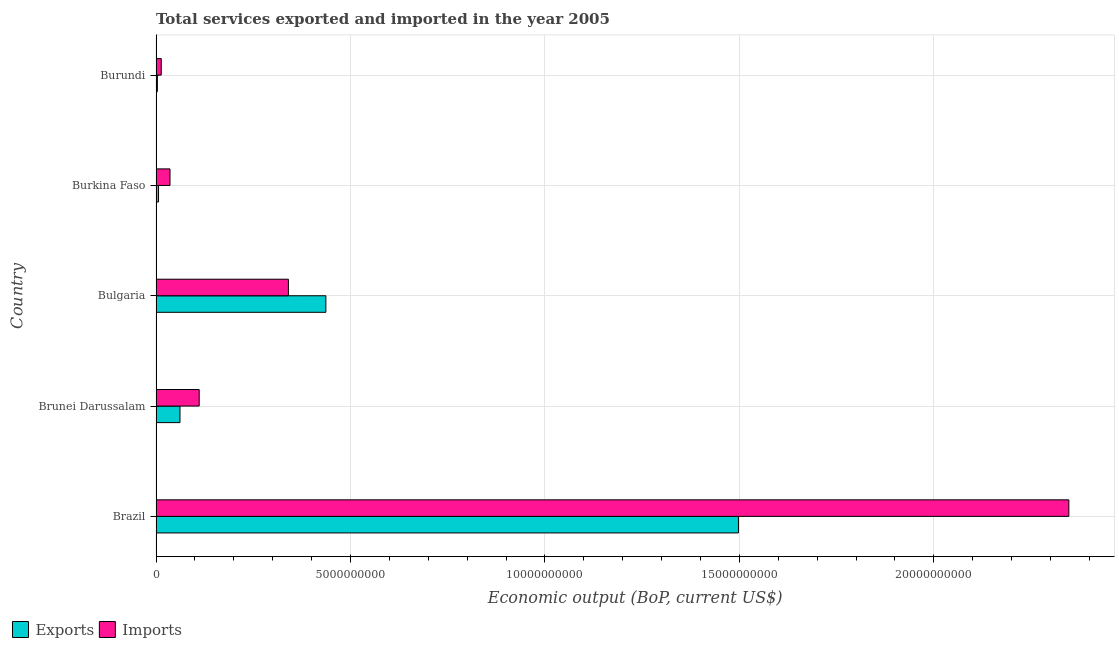Are the number of bars on each tick of the Y-axis equal?
Provide a succinct answer. Yes. How many bars are there on the 4th tick from the top?
Ensure brevity in your answer.  2. How many bars are there on the 1st tick from the bottom?
Keep it short and to the point. 2. What is the label of the 1st group of bars from the top?
Your response must be concise. Burundi. What is the amount of service exports in Brunei Darussalam?
Keep it short and to the point. 6.16e+08. Across all countries, what is the maximum amount of service exports?
Provide a succinct answer. 1.50e+1. Across all countries, what is the minimum amount of service exports?
Make the answer very short. 3.48e+07. In which country was the amount of service exports maximum?
Make the answer very short. Brazil. In which country was the amount of service imports minimum?
Your answer should be very brief. Burundi. What is the total amount of service exports in the graph?
Keep it short and to the point. 2.01e+1. What is the difference between the amount of service exports in Brazil and that in Bulgaria?
Your answer should be very brief. 1.06e+1. What is the difference between the amount of service exports in Brazil and the amount of service imports in Burkina Faso?
Give a very brief answer. 1.46e+1. What is the average amount of service exports per country?
Keep it short and to the point. 4.01e+09. What is the difference between the amount of service exports and amount of service imports in Brazil?
Give a very brief answer. -8.50e+09. What is the ratio of the amount of service imports in Burkina Faso to that in Burundi?
Offer a very short reply. 2.68. Is the amount of service exports in Brazil less than that in Bulgaria?
Keep it short and to the point. No. What is the difference between the highest and the second highest amount of service imports?
Your answer should be very brief. 2.01e+1. What is the difference between the highest and the lowest amount of service imports?
Keep it short and to the point. 2.33e+1. What does the 2nd bar from the top in Brunei Darussalam represents?
Provide a short and direct response. Exports. What does the 2nd bar from the bottom in Brunei Darussalam represents?
Your response must be concise. Imports. How many bars are there?
Offer a very short reply. 10. How many countries are there in the graph?
Your answer should be compact. 5. Where does the legend appear in the graph?
Your answer should be very brief. Bottom left. How are the legend labels stacked?
Your answer should be very brief. Horizontal. What is the title of the graph?
Offer a very short reply. Total services exported and imported in the year 2005. Does "Time to import" appear as one of the legend labels in the graph?
Your answer should be very brief. No. What is the label or title of the X-axis?
Provide a short and direct response. Economic output (BoP, current US$). What is the Economic output (BoP, current US$) of Exports in Brazil?
Keep it short and to the point. 1.50e+1. What is the Economic output (BoP, current US$) of Imports in Brazil?
Provide a succinct answer. 2.35e+1. What is the Economic output (BoP, current US$) in Exports in Brunei Darussalam?
Ensure brevity in your answer.  6.16e+08. What is the Economic output (BoP, current US$) of Imports in Brunei Darussalam?
Ensure brevity in your answer.  1.11e+09. What is the Economic output (BoP, current US$) of Exports in Bulgaria?
Your answer should be very brief. 4.37e+09. What is the Economic output (BoP, current US$) in Imports in Bulgaria?
Your answer should be compact. 3.40e+09. What is the Economic output (BoP, current US$) of Exports in Burkina Faso?
Provide a succinct answer. 6.43e+07. What is the Economic output (BoP, current US$) in Imports in Burkina Faso?
Ensure brevity in your answer.  3.59e+08. What is the Economic output (BoP, current US$) of Exports in Burundi?
Your answer should be compact. 3.48e+07. What is the Economic output (BoP, current US$) in Imports in Burundi?
Keep it short and to the point. 1.34e+08. Across all countries, what is the maximum Economic output (BoP, current US$) of Exports?
Your answer should be compact. 1.50e+1. Across all countries, what is the maximum Economic output (BoP, current US$) in Imports?
Provide a succinct answer. 2.35e+1. Across all countries, what is the minimum Economic output (BoP, current US$) of Exports?
Your response must be concise. 3.48e+07. Across all countries, what is the minimum Economic output (BoP, current US$) of Imports?
Your answer should be very brief. 1.34e+08. What is the total Economic output (BoP, current US$) in Exports in the graph?
Your response must be concise. 2.01e+1. What is the total Economic output (BoP, current US$) of Imports in the graph?
Give a very brief answer. 2.85e+1. What is the difference between the Economic output (BoP, current US$) in Exports in Brazil and that in Brunei Darussalam?
Provide a succinct answer. 1.44e+1. What is the difference between the Economic output (BoP, current US$) of Imports in Brazil and that in Brunei Darussalam?
Make the answer very short. 2.24e+1. What is the difference between the Economic output (BoP, current US$) of Exports in Brazil and that in Bulgaria?
Offer a very short reply. 1.06e+1. What is the difference between the Economic output (BoP, current US$) in Imports in Brazil and that in Bulgaria?
Make the answer very short. 2.01e+1. What is the difference between the Economic output (BoP, current US$) in Exports in Brazil and that in Burkina Faso?
Your response must be concise. 1.49e+1. What is the difference between the Economic output (BoP, current US$) in Imports in Brazil and that in Burkina Faso?
Your response must be concise. 2.31e+1. What is the difference between the Economic output (BoP, current US$) in Exports in Brazil and that in Burundi?
Offer a terse response. 1.49e+1. What is the difference between the Economic output (BoP, current US$) of Imports in Brazil and that in Burundi?
Your answer should be very brief. 2.33e+1. What is the difference between the Economic output (BoP, current US$) in Exports in Brunei Darussalam and that in Bulgaria?
Your answer should be very brief. -3.75e+09. What is the difference between the Economic output (BoP, current US$) in Imports in Brunei Darussalam and that in Bulgaria?
Your response must be concise. -2.29e+09. What is the difference between the Economic output (BoP, current US$) in Exports in Brunei Darussalam and that in Burkina Faso?
Your answer should be very brief. 5.52e+08. What is the difference between the Economic output (BoP, current US$) in Imports in Brunei Darussalam and that in Burkina Faso?
Ensure brevity in your answer.  7.51e+08. What is the difference between the Economic output (BoP, current US$) in Exports in Brunei Darussalam and that in Burundi?
Keep it short and to the point. 5.81e+08. What is the difference between the Economic output (BoP, current US$) in Imports in Brunei Darussalam and that in Burundi?
Your answer should be compact. 9.76e+08. What is the difference between the Economic output (BoP, current US$) in Exports in Bulgaria and that in Burkina Faso?
Your answer should be very brief. 4.30e+09. What is the difference between the Economic output (BoP, current US$) in Imports in Bulgaria and that in Burkina Faso?
Offer a terse response. 3.04e+09. What is the difference between the Economic output (BoP, current US$) of Exports in Bulgaria and that in Burundi?
Give a very brief answer. 4.33e+09. What is the difference between the Economic output (BoP, current US$) of Imports in Bulgaria and that in Burundi?
Give a very brief answer. 3.27e+09. What is the difference between the Economic output (BoP, current US$) in Exports in Burkina Faso and that in Burundi?
Your answer should be very brief. 2.95e+07. What is the difference between the Economic output (BoP, current US$) of Imports in Burkina Faso and that in Burundi?
Your answer should be very brief. 2.25e+08. What is the difference between the Economic output (BoP, current US$) of Exports in Brazil and the Economic output (BoP, current US$) of Imports in Brunei Darussalam?
Ensure brevity in your answer.  1.39e+1. What is the difference between the Economic output (BoP, current US$) in Exports in Brazil and the Economic output (BoP, current US$) in Imports in Bulgaria?
Make the answer very short. 1.16e+1. What is the difference between the Economic output (BoP, current US$) of Exports in Brazil and the Economic output (BoP, current US$) of Imports in Burkina Faso?
Offer a very short reply. 1.46e+1. What is the difference between the Economic output (BoP, current US$) of Exports in Brazil and the Economic output (BoP, current US$) of Imports in Burundi?
Your answer should be compact. 1.48e+1. What is the difference between the Economic output (BoP, current US$) in Exports in Brunei Darussalam and the Economic output (BoP, current US$) in Imports in Bulgaria?
Keep it short and to the point. -2.79e+09. What is the difference between the Economic output (BoP, current US$) of Exports in Brunei Darussalam and the Economic output (BoP, current US$) of Imports in Burkina Faso?
Keep it short and to the point. 2.57e+08. What is the difference between the Economic output (BoP, current US$) of Exports in Brunei Darussalam and the Economic output (BoP, current US$) of Imports in Burundi?
Keep it short and to the point. 4.82e+08. What is the difference between the Economic output (BoP, current US$) of Exports in Bulgaria and the Economic output (BoP, current US$) of Imports in Burkina Faso?
Offer a terse response. 4.01e+09. What is the difference between the Economic output (BoP, current US$) in Exports in Bulgaria and the Economic output (BoP, current US$) in Imports in Burundi?
Provide a short and direct response. 4.23e+09. What is the difference between the Economic output (BoP, current US$) of Exports in Burkina Faso and the Economic output (BoP, current US$) of Imports in Burundi?
Your response must be concise. -6.97e+07. What is the average Economic output (BoP, current US$) of Exports per country?
Provide a succinct answer. 4.01e+09. What is the average Economic output (BoP, current US$) in Imports per country?
Keep it short and to the point. 5.70e+09. What is the difference between the Economic output (BoP, current US$) of Exports and Economic output (BoP, current US$) of Imports in Brazil?
Give a very brief answer. -8.50e+09. What is the difference between the Economic output (BoP, current US$) of Exports and Economic output (BoP, current US$) of Imports in Brunei Darussalam?
Your answer should be compact. -4.94e+08. What is the difference between the Economic output (BoP, current US$) in Exports and Economic output (BoP, current US$) in Imports in Bulgaria?
Ensure brevity in your answer.  9.63e+08. What is the difference between the Economic output (BoP, current US$) in Exports and Economic output (BoP, current US$) in Imports in Burkina Faso?
Provide a short and direct response. -2.95e+08. What is the difference between the Economic output (BoP, current US$) of Exports and Economic output (BoP, current US$) of Imports in Burundi?
Provide a short and direct response. -9.93e+07. What is the ratio of the Economic output (BoP, current US$) of Exports in Brazil to that in Brunei Darussalam?
Provide a succinct answer. 24.31. What is the ratio of the Economic output (BoP, current US$) of Imports in Brazil to that in Brunei Darussalam?
Your answer should be very brief. 21.14. What is the ratio of the Economic output (BoP, current US$) of Exports in Brazil to that in Bulgaria?
Make the answer very short. 3.43. What is the ratio of the Economic output (BoP, current US$) of Imports in Brazil to that in Bulgaria?
Give a very brief answer. 6.9. What is the ratio of the Economic output (BoP, current US$) in Exports in Brazil to that in Burkina Faso?
Your answer should be very brief. 232.79. What is the ratio of the Economic output (BoP, current US$) in Imports in Brazil to that in Burkina Faso?
Your answer should be very brief. 65.34. What is the ratio of the Economic output (BoP, current US$) of Exports in Brazil to that in Burundi?
Your answer should be very brief. 430.43. What is the ratio of the Economic output (BoP, current US$) of Imports in Brazil to that in Burundi?
Your answer should be very brief. 175.05. What is the ratio of the Economic output (BoP, current US$) of Exports in Brunei Darussalam to that in Bulgaria?
Your answer should be very brief. 0.14. What is the ratio of the Economic output (BoP, current US$) in Imports in Brunei Darussalam to that in Bulgaria?
Give a very brief answer. 0.33. What is the ratio of the Economic output (BoP, current US$) of Exports in Brunei Darussalam to that in Burkina Faso?
Give a very brief answer. 9.58. What is the ratio of the Economic output (BoP, current US$) in Imports in Brunei Darussalam to that in Burkina Faso?
Your response must be concise. 3.09. What is the ratio of the Economic output (BoP, current US$) in Exports in Brunei Darussalam to that in Burundi?
Provide a short and direct response. 17.71. What is the ratio of the Economic output (BoP, current US$) of Imports in Brunei Darussalam to that in Burundi?
Ensure brevity in your answer.  8.28. What is the ratio of the Economic output (BoP, current US$) of Exports in Bulgaria to that in Burkina Faso?
Offer a very short reply. 67.89. What is the ratio of the Economic output (BoP, current US$) of Imports in Bulgaria to that in Burkina Faso?
Give a very brief answer. 9.48. What is the ratio of the Economic output (BoP, current US$) of Exports in Bulgaria to that in Burundi?
Your answer should be compact. 125.52. What is the ratio of the Economic output (BoP, current US$) in Imports in Bulgaria to that in Burundi?
Keep it short and to the point. 25.39. What is the ratio of the Economic output (BoP, current US$) of Exports in Burkina Faso to that in Burundi?
Keep it short and to the point. 1.85. What is the ratio of the Economic output (BoP, current US$) in Imports in Burkina Faso to that in Burundi?
Your response must be concise. 2.68. What is the difference between the highest and the second highest Economic output (BoP, current US$) of Exports?
Your answer should be compact. 1.06e+1. What is the difference between the highest and the second highest Economic output (BoP, current US$) of Imports?
Offer a very short reply. 2.01e+1. What is the difference between the highest and the lowest Economic output (BoP, current US$) of Exports?
Ensure brevity in your answer.  1.49e+1. What is the difference between the highest and the lowest Economic output (BoP, current US$) in Imports?
Your answer should be very brief. 2.33e+1. 